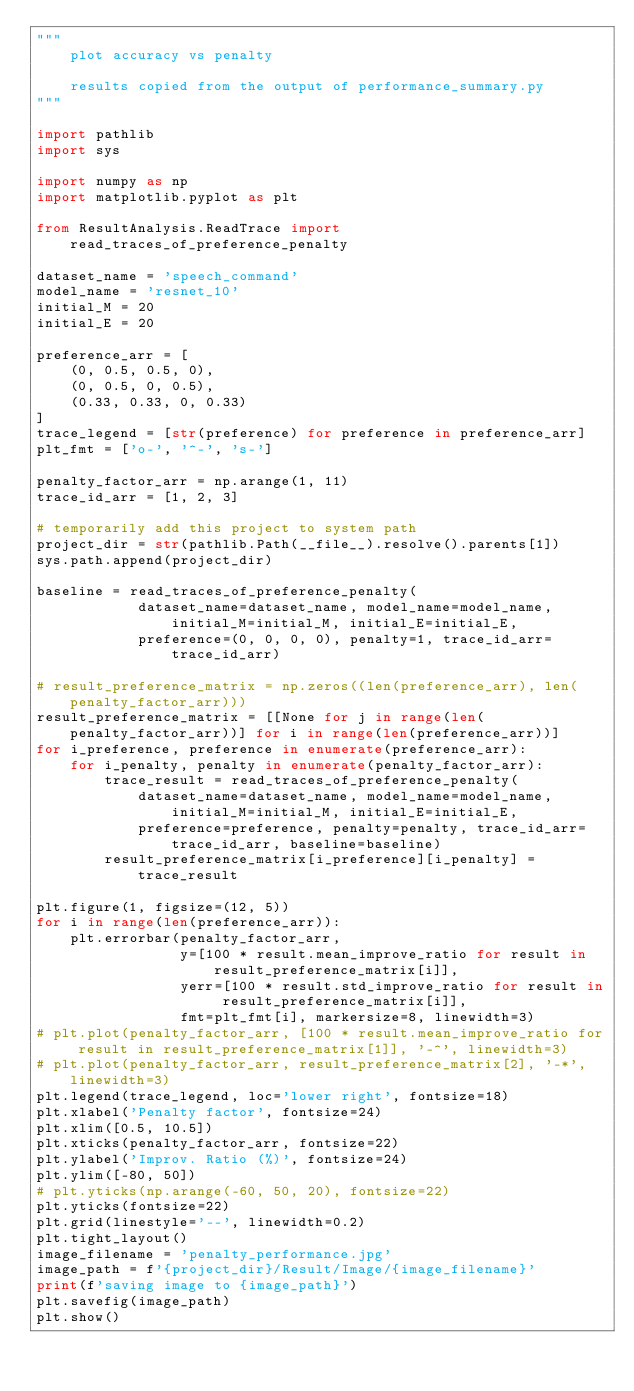Convert code to text. <code><loc_0><loc_0><loc_500><loc_500><_Python_>"""
    plot accuracy vs penalty

    results copied from the output of performance_summary.py
"""

import pathlib
import sys

import numpy as np
import matplotlib.pyplot as plt

from ResultAnalysis.ReadTrace import read_traces_of_preference_penalty

dataset_name = 'speech_command'
model_name = 'resnet_10'
initial_M = 20
initial_E = 20

preference_arr = [
    (0, 0.5, 0.5, 0),
    (0, 0.5, 0, 0.5),
    (0.33, 0.33, 0, 0.33)
]
trace_legend = [str(preference) for preference in preference_arr]
plt_fmt = ['o-', '^-', 's-']

penalty_factor_arr = np.arange(1, 11)
trace_id_arr = [1, 2, 3]

# temporarily add this project to system path
project_dir = str(pathlib.Path(__file__).resolve().parents[1])
sys.path.append(project_dir)

baseline = read_traces_of_preference_penalty(
            dataset_name=dataset_name, model_name=model_name, initial_M=initial_M, initial_E=initial_E,
            preference=(0, 0, 0, 0), penalty=1, trace_id_arr=trace_id_arr)

# result_preference_matrix = np.zeros((len(preference_arr), len(penalty_factor_arr)))
result_preference_matrix = [[None for j in range(len(penalty_factor_arr))] for i in range(len(preference_arr))]
for i_preference, preference in enumerate(preference_arr):
    for i_penalty, penalty in enumerate(penalty_factor_arr):
        trace_result = read_traces_of_preference_penalty(
            dataset_name=dataset_name, model_name=model_name, initial_M=initial_M, initial_E=initial_E,
            preference=preference, penalty=penalty, trace_id_arr=trace_id_arr, baseline=baseline)
        result_preference_matrix[i_preference][i_penalty] = trace_result

plt.figure(1, figsize=(12, 5))
for i in range(len(preference_arr)):
    plt.errorbar(penalty_factor_arr,
                 y=[100 * result.mean_improve_ratio for result in result_preference_matrix[i]],
                 yerr=[100 * result.std_improve_ratio for result in result_preference_matrix[i]],
                 fmt=plt_fmt[i], markersize=8, linewidth=3)
# plt.plot(penalty_factor_arr, [100 * result.mean_improve_ratio for result in result_preference_matrix[1]], '-^', linewidth=3)
# plt.plot(penalty_factor_arr, result_preference_matrix[2], '-*', linewidth=3)
plt.legend(trace_legend, loc='lower right', fontsize=18)
plt.xlabel('Penalty factor', fontsize=24)
plt.xlim([0.5, 10.5])
plt.xticks(penalty_factor_arr, fontsize=22)
plt.ylabel('Improv. Ratio (%)', fontsize=24)
plt.ylim([-80, 50])
# plt.yticks(np.arange(-60, 50, 20), fontsize=22)
plt.yticks(fontsize=22)
plt.grid(linestyle='--', linewidth=0.2)
plt.tight_layout()
image_filename = 'penalty_performance.jpg'
image_path = f'{project_dir}/Result/Image/{image_filename}'
print(f'saving image to {image_path}')
plt.savefig(image_path)
plt.show()



</code> 